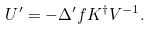<formula> <loc_0><loc_0><loc_500><loc_500>U ^ { \prime } = - \Delta ^ { \prime } f K ^ { \dag } V ^ { - 1 } .</formula> 